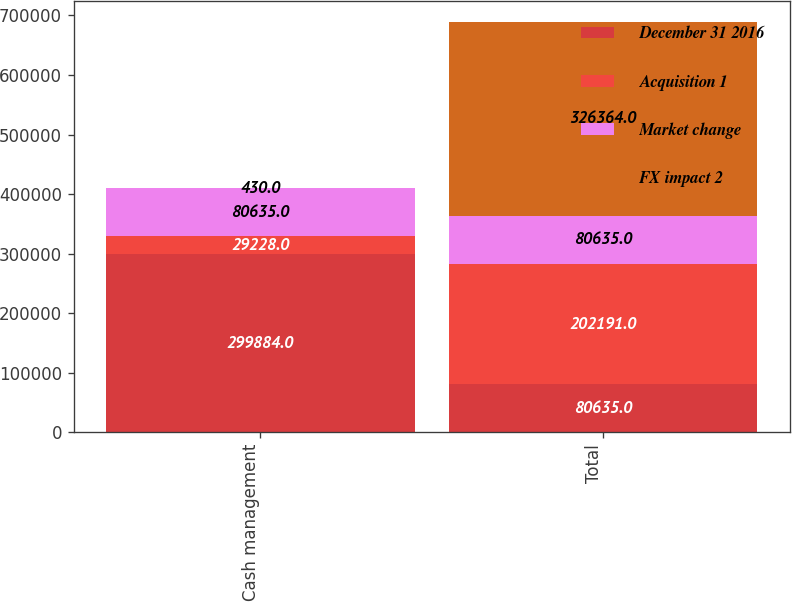Convert chart to OTSL. <chart><loc_0><loc_0><loc_500><loc_500><stacked_bar_chart><ecel><fcel>Cash management<fcel>Total<nl><fcel>December 31 2016<fcel>299884<fcel>80635<nl><fcel>Acquisition 1<fcel>29228<fcel>202191<nl><fcel>Market change<fcel>80635<fcel>80635<nl><fcel>FX impact 2<fcel>430<fcel>326364<nl></chart> 